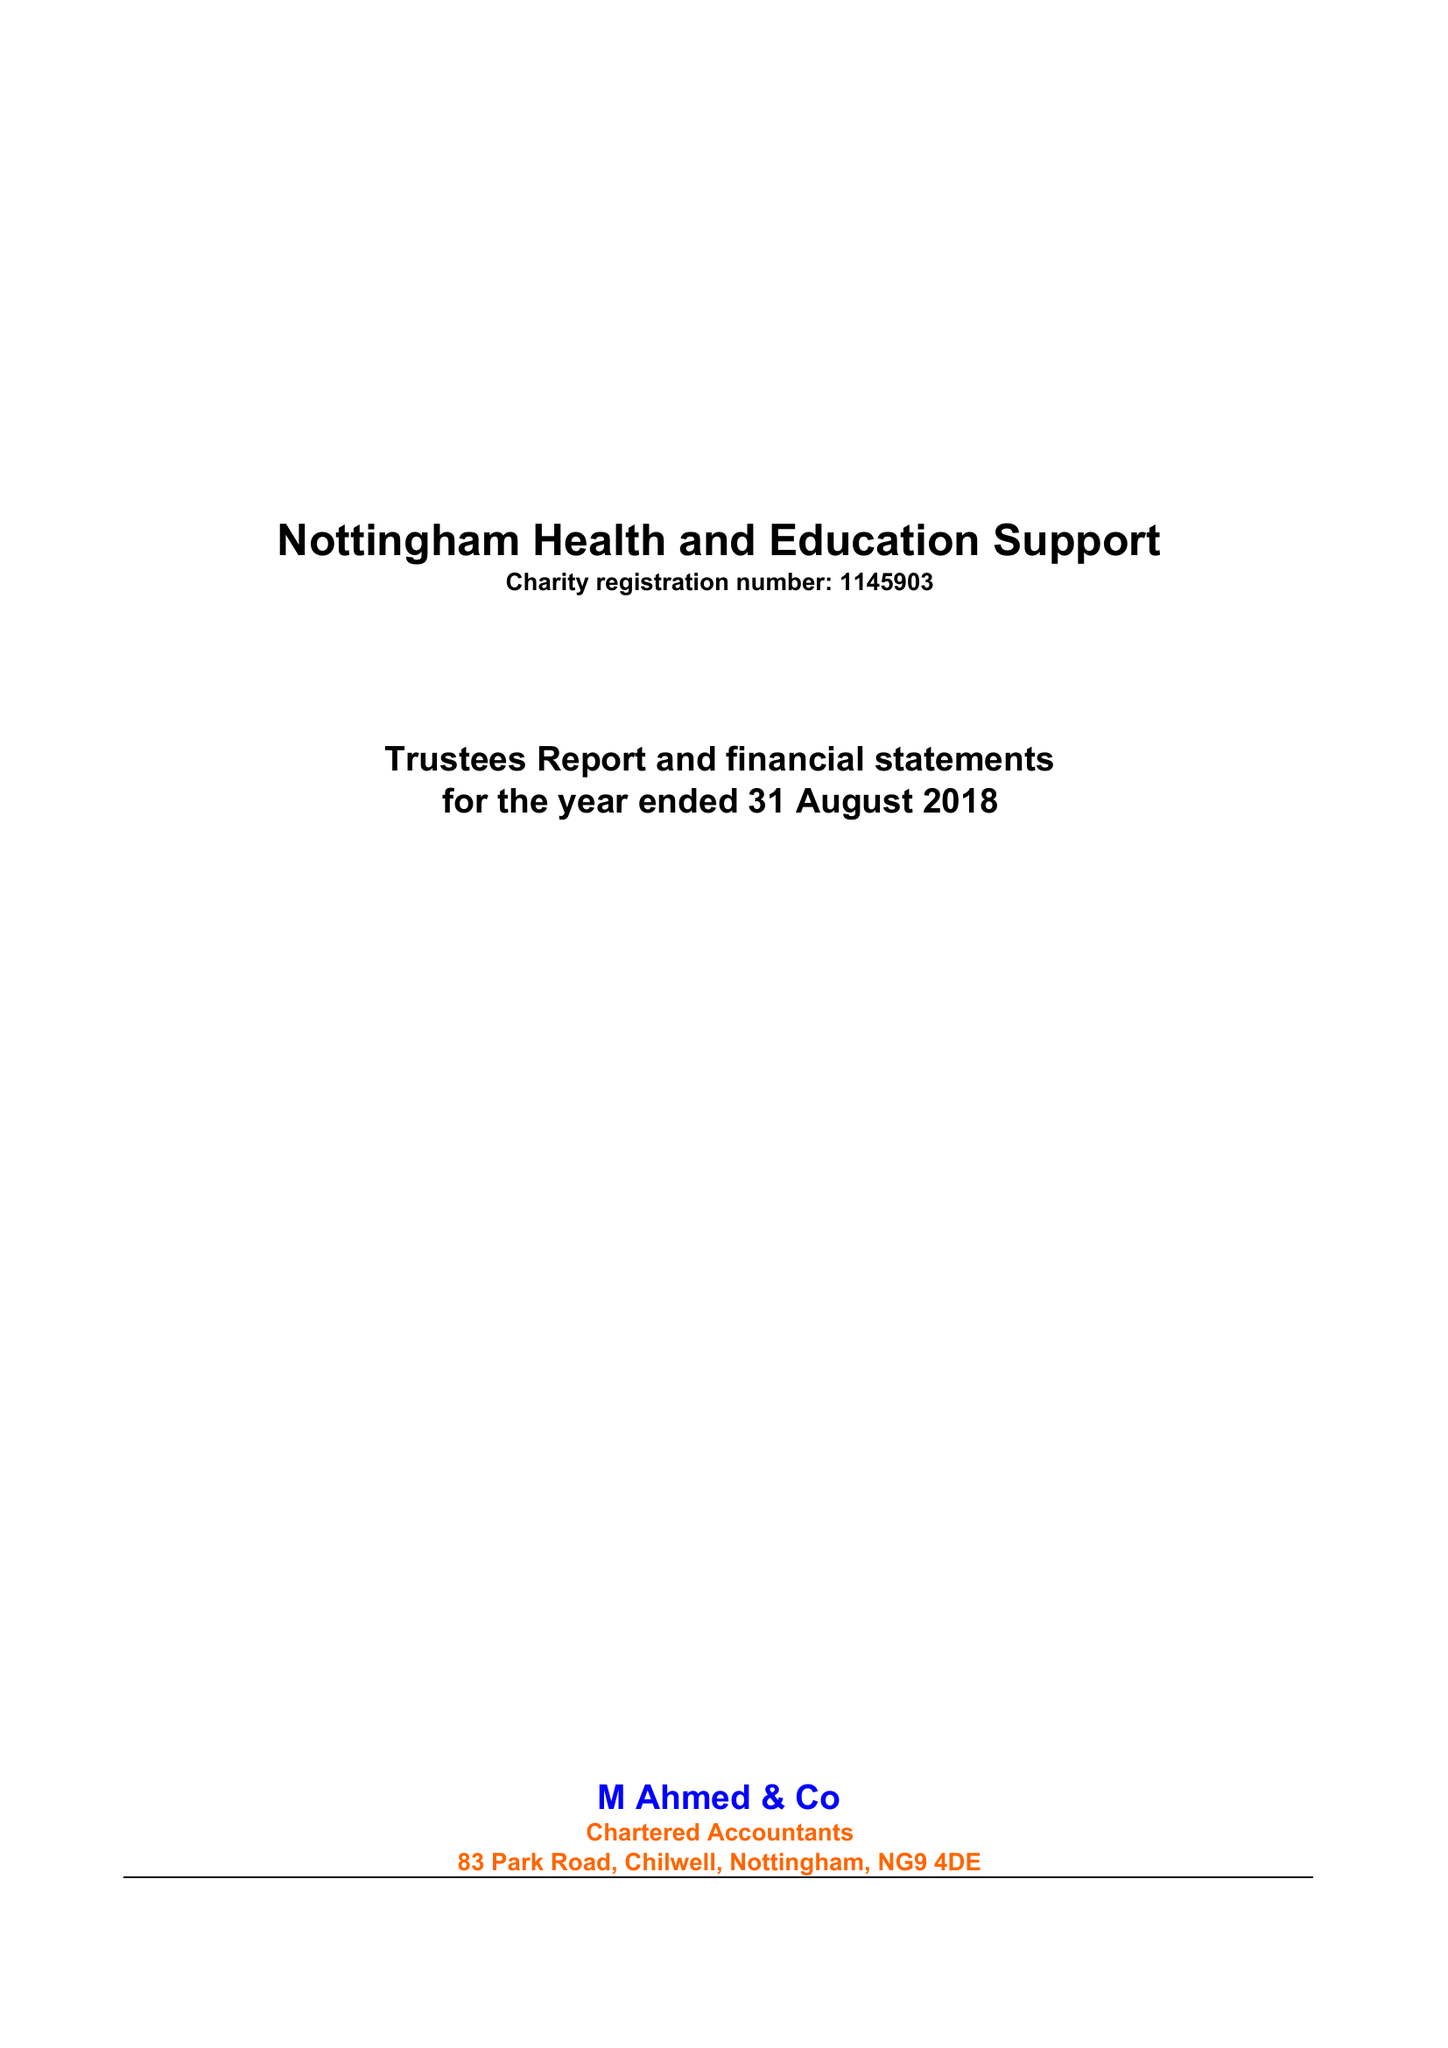What is the value for the income_annually_in_british_pounds?
Answer the question using a single word or phrase. 68339.00 